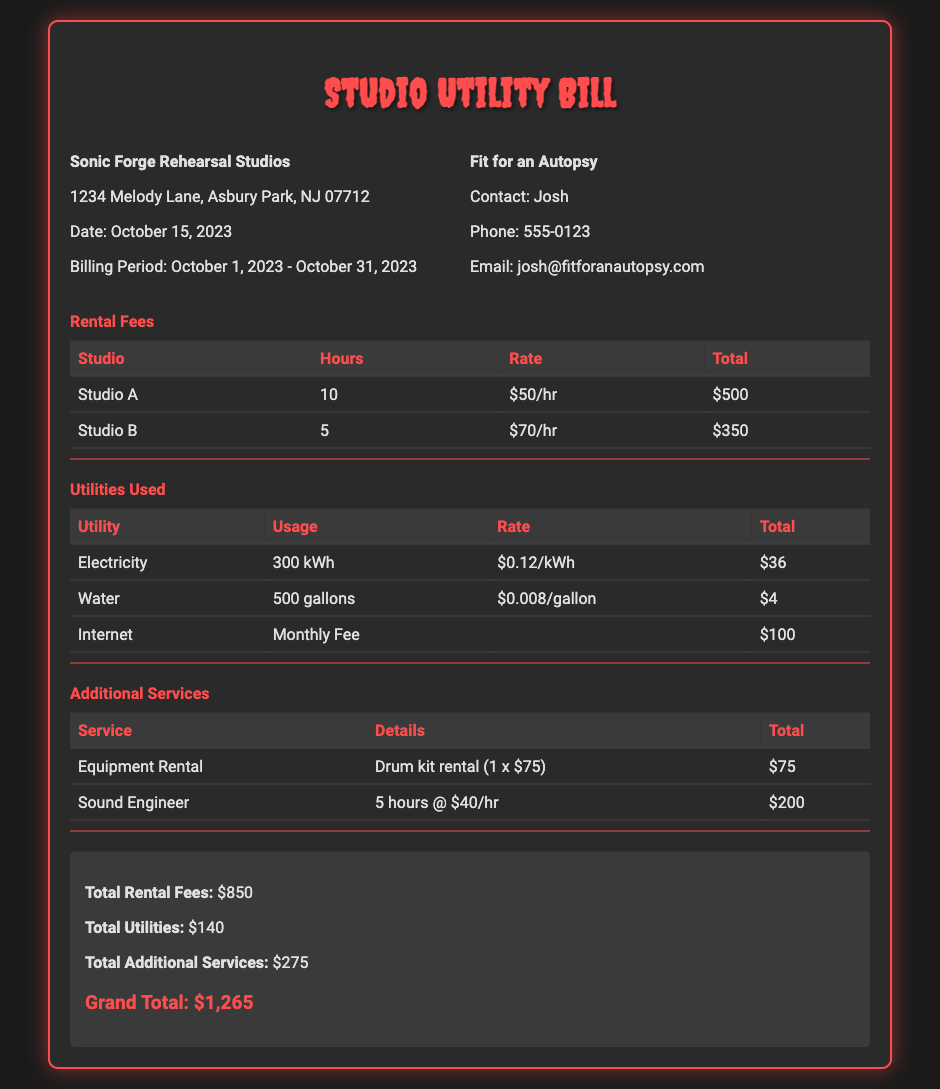what is the date of the bill? The date of the bill is explicitly mentioned in the document header.
Answer: October 15, 2023 what is the total for Studio A rental? The total for Studio A is found in the rental fees section of the document.
Answer: $500 how many gallons of water were used? The usage of water is specified in the utilities used section.
Answer: 500 gallons what is the total for additional services? The total for additional services is calculated at the bottom of that section.
Answer: $275 who is the contact person for the band? The document lists the contact person's name under the band information.
Answer: Josh what is the total amount for utilities used? The total for utilities is provided in the summary section.
Answer: $140 how many hours were Studio B rented for? The rental hours for Studio B are stated in the rental fees table.
Answer: 5 what is the rate for electricity usage? The rate for electricity is found in the utilities used section of the document.
Answer: $0.12/kWh what is the grand total amount due? The grand total is clearly listed in the summary section at the end of the document.
Answer: $1,265 